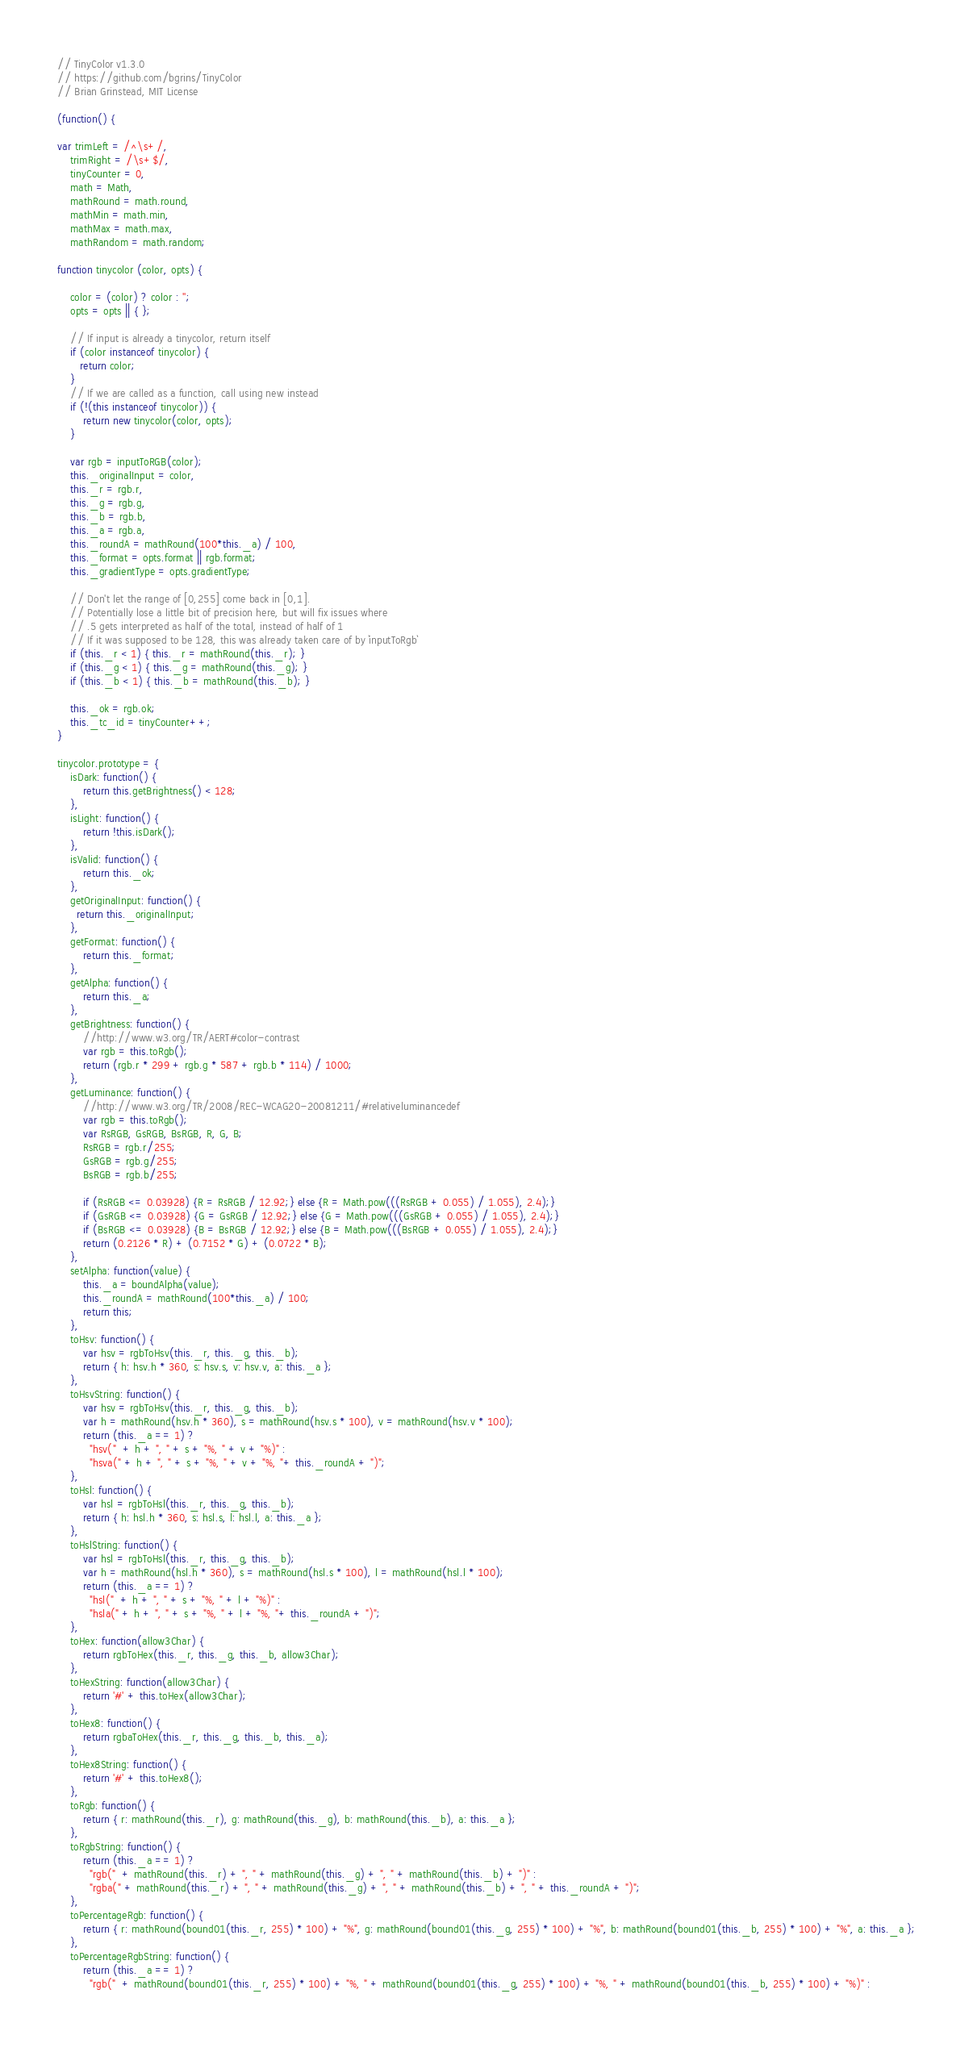Convert code to text. <code><loc_0><loc_0><loc_500><loc_500><_JavaScript_>// TinyColor v1.3.0
// https://github.com/bgrins/TinyColor
// Brian Grinstead, MIT License

(function() {

var trimLeft = /^\s+/,
    trimRight = /\s+$/,
    tinyCounter = 0,
    math = Math,
    mathRound = math.round,
    mathMin = math.min,
    mathMax = math.max,
    mathRandom = math.random;

function tinycolor (color, opts) {

    color = (color) ? color : '';
    opts = opts || { };

    // If input is already a tinycolor, return itself
    if (color instanceof tinycolor) {
       return color;
    }
    // If we are called as a function, call using new instead
    if (!(this instanceof tinycolor)) {
        return new tinycolor(color, opts);
    }

    var rgb = inputToRGB(color);
    this._originalInput = color,
    this._r = rgb.r,
    this._g = rgb.g,
    this._b = rgb.b,
    this._a = rgb.a,
    this._roundA = mathRound(100*this._a) / 100,
    this._format = opts.format || rgb.format;
    this._gradientType = opts.gradientType;

    // Don't let the range of [0,255] come back in [0,1].
    // Potentially lose a little bit of precision here, but will fix issues where
    // .5 gets interpreted as half of the total, instead of half of 1
    // If it was supposed to be 128, this was already taken care of by `inputToRgb`
    if (this._r < 1) { this._r = mathRound(this._r); }
    if (this._g < 1) { this._g = mathRound(this._g); }
    if (this._b < 1) { this._b = mathRound(this._b); }

    this._ok = rgb.ok;
    this._tc_id = tinyCounter++;
}

tinycolor.prototype = {
    isDark: function() {
        return this.getBrightness() < 128;
    },
    isLight: function() {
        return !this.isDark();
    },
    isValid: function() {
        return this._ok;
    },
    getOriginalInput: function() {
      return this._originalInput;
    },
    getFormat: function() {
        return this._format;
    },
    getAlpha: function() {
        return this._a;
    },
    getBrightness: function() {
        //http://www.w3.org/TR/AERT#color-contrast
        var rgb = this.toRgb();
        return (rgb.r * 299 + rgb.g * 587 + rgb.b * 114) / 1000;
    },
    getLuminance: function() {
        //http://www.w3.org/TR/2008/REC-WCAG20-20081211/#relativeluminancedef
        var rgb = this.toRgb();
        var RsRGB, GsRGB, BsRGB, R, G, B;
        RsRGB = rgb.r/255;
        GsRGB = rgb.g/255;
        BsRGB = rgb.b/255;

        if (RsRGB <= 0.03928) {R = RsRGB / 12.92;} else {R = Math.pow(((RsRGB + 0.055) / 1.055), 2.4);}
        if (GsRGB <= 0.03928) {G = GsRGB / 12.92;} else {G = Math.pow(((GsRGB + 0.055) / 1.055), 2.4);}
        if (BsRGB <= 0.03928) {B = BsRGB / 12.92;} else {B = Math.pow(((BsRGB + 0.055) / 1.055), 2.4);}
        return (0.2126 * R) + (0.7152 * G) + (0.0722 * B);
    },
    setAlpha: function(value) {
        this._a = boundAlpha(value);
        this._roundA = mathRound(100*this._a) / 100;
        return this;
    },
    toHsv: function() {
        var hsv = rgbToHsv(this._r, this._g, this._b);
        return { h: hsv.h * 360, s: hsv.s, v: hsv.v, a: this._a };
    },
    toHsvString: function() {
        var hsv = rgbToHsv(this._r, this._g, this._b);
        var h = mathRound(hsv.h * 360), s = mathRound(hsv.s * 100), v = mathRound(hsv.v * 100);
        return (this._a == 1) ?
          "hsv("  + h + ", " + s + "%, " + v + "%)" :
          "hsva(" + h + ", " + s + "%, " + v + "%, "+ this._roundA + ")";
    },
    toHsl: function() {
        var hsl = rgbToHsl(this._r, this._g, this._b);
        return { h: hsl.h * 360, s: hsl.s, l: hsl.l, a: this._a };
    },
    toHslString: function() {
        var hsl = rgbToHsl(this._r, this._g, this._b);
        var h = mathRound(hsl.h * 360), s = mathRound(hsl.s * 100), l = mathRound(hsl.l * 100);
        return (this._a == 1) ?
          "hsl("  + h + ", " + s + "%, " + l + "%)" :
          "hsla(" + h + ", " + s + "%, " + l + "%, "+ this._roundA + ")";
    },
    toHex: function(allow3Char) {
        return rgbToHex(this._r, this._g, this._b, allow3Char);
    },
    toHexString: function(allow3Char) {
        return '#' + this.toHex(allow3Char);
    },
    toHex8: function() {
        return rgbaToHex(this._r, this._g, this._b, this._a);
    },
    toHex8String: function() {
        return '#' + this.toHex8();
    },
    toRgb: function() {
        return { r: mathRound(this._r), g: mathRound(this._g), b: mathRound(this._b), a: this._a };
    },
    toRgbString: function() {
        return (this._a == 1) ?
          "rgb("  + mathRound(this._r) + ", " + mathRound(this._g) + ", " + mathRound(this._b) + ")" :
          "rgba(" + mathRound(this._r) + ", " + mathRound(this._g) + ", " + mathRound(this._b) + ", " + this._roundA + ")";
    },
    toPercentageRgb: function() {
        return { r: mathRound(bound01(this._r, 255) * 100) + "%", g: mathRound(bound01(this._g, 255) * 100) + "%", b: mathRound(bound01(this._b, 255) * 100) + "%", a: this._a };
    },
    toPercentageRgbString: function() {
        return (this._a == 1) ?
          "rgb("  + mathRound(bound01(this._r, 255) * 100) + "%, " + mathRound(bound01(this._g, 255) * 100) + "%, " + mathRound(bound01(this._b, 255) * 100) + "%)" :</code> 